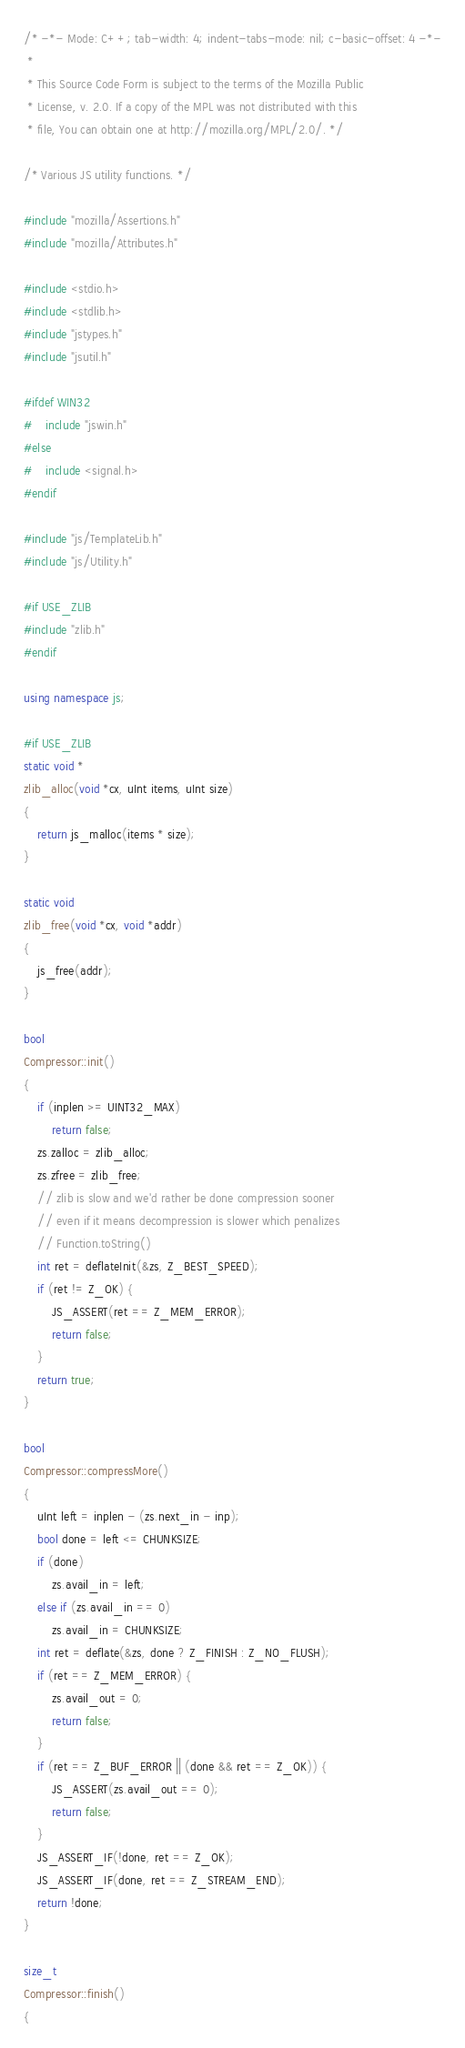<code> <loc_0><loc_0><loc_500><loc_500><_C++_>/* -*- Mode: C++; tab-width: 4; indent-tabs-mode: nil; c-basic-offset: 4 -*-
 *
 * This Source Code Form is subject to the terms of the Mozilla Public
 * License, v. 2.0. If a copy of the MPL was not distributed with this
 * file, You can obtain one at http://mozilla.org/MPL/2.0/. */

/* Various JS utility functions. */

#include "mozilla/Assertions.h"
#include "mozilla/Attributes.h"

#include <stdio.h>
#include <stdlib.h>
#include "jstypes.h"
#include "jsutil.h"

#ifdef WIN32
#    include "jswin.h"
#else
#    include <signal.h>
#endif

#include "js/TemplateLib.h"
#include "js/Utility.h"

#if USE_ZLIB
#include "zlib.h"
#endif

using namespace js;

#if USE_ZLIB
static void *
zlib_alloc(void *cx, uInt items, uInt size)
{
    return js_malloc(items * size);
}

static void
zlib_free(void *cx, void *addr)
{
    js_free(addr);
}

bool
Compressor::init()
{
    if (inplen >= UINT32_MAX)
        return false;
    zs.zalloc = zlib_alloc;
    zs.zfree = zlib_free;
    // zlib is slow and we'd rather be done compression sooner
    // even if it means decompression is slower which penalizes
    // Function.toString()
    int ret = deflateInit(&zs, Z_BEST_SPEED);
    if (ret != Z_OK) {
        JS_ASSERT(ret == Z_MEM_ERROR);
        return false;
    }
    return true;
}

bool
Compressor::compressMore()
{
    uInt left = inplen - (zs.next_in - inp);
    bool done = left <= CHUNKSIZE;
    if (done)
        zs.avail_in = left;
    else if (zs.avail_in == 0)
        zs.avail_in = CHUNKSIZE;
    int ret = deflate(&zs, done ? Z_FINISH : Z_NO_FLUSH);
    if (ret == Z_MEM_ERROR) {
        zs.avail_out = 0;
        return false;
    }
    if (ret == Z_BUF_ERROR || (done && ret == Z_OK)) {
        JS_ASSERT(zs.avail_out == 0);
        return false;
    }
    JS_ASSERT_IF(!done, ret == Z_OK);
    JS_ASSERT_IF(done, ret == Z_STREAM_END);
    return !done;
}

size_t
Compressor::finish()
{</code> 